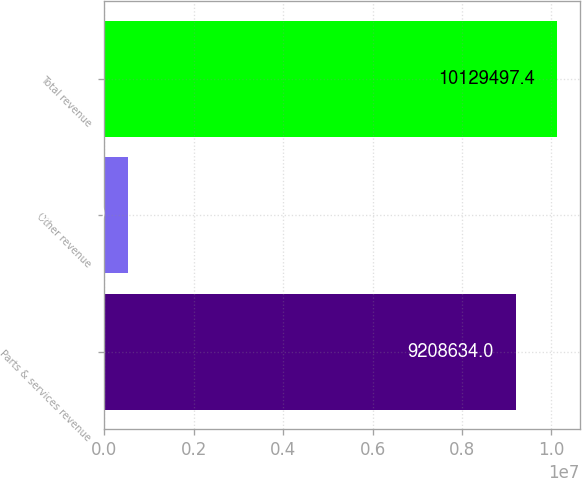Convert chart. <chart><loc_0><loc_0><loc_500><loc_500><bar_chart><fcel>Parts & services revenue<fcel>Other revenue<fcel>Total revenue<nl><fcel>9.20863e+06<fcel>528275<fcel>1.01295e+07<nl></chart> 